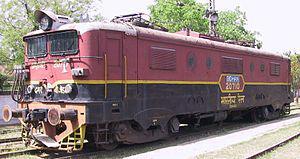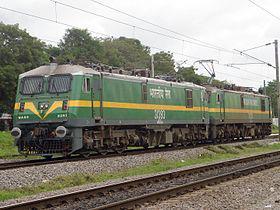The first image is the image on the left, the second image is the image on the right. For the images displayed, is the sentence "The train in one of the images is green and yellow." factually correct? Answer yes or no. Yes. The first image is the image on the left, the second image is the image on the right. Considering the images on both sides, is "The trains in both images travel on straight tracks in the same direction." valid? Answer yes or no. Yes. 